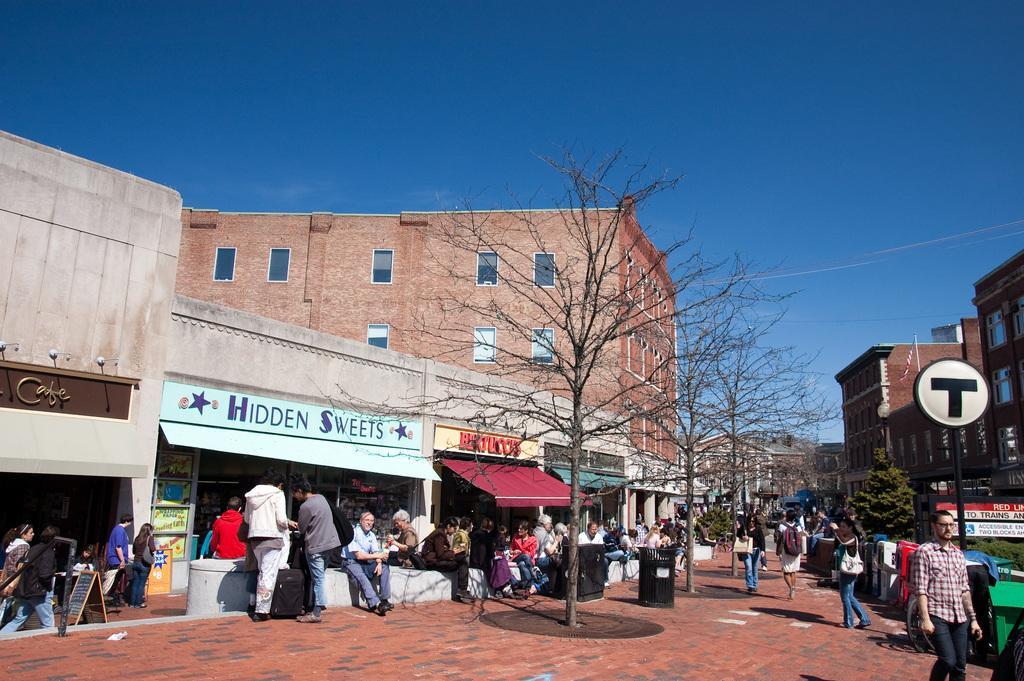How would you summarize this image in a sentence or two? There are few persons sitting on the platform and few are walking on the footpath and among them few persons are carrying bags on their shoulders. In the background there are bare trees, trees, buildings, name boards on the wall, windows, hoardings and sky. 